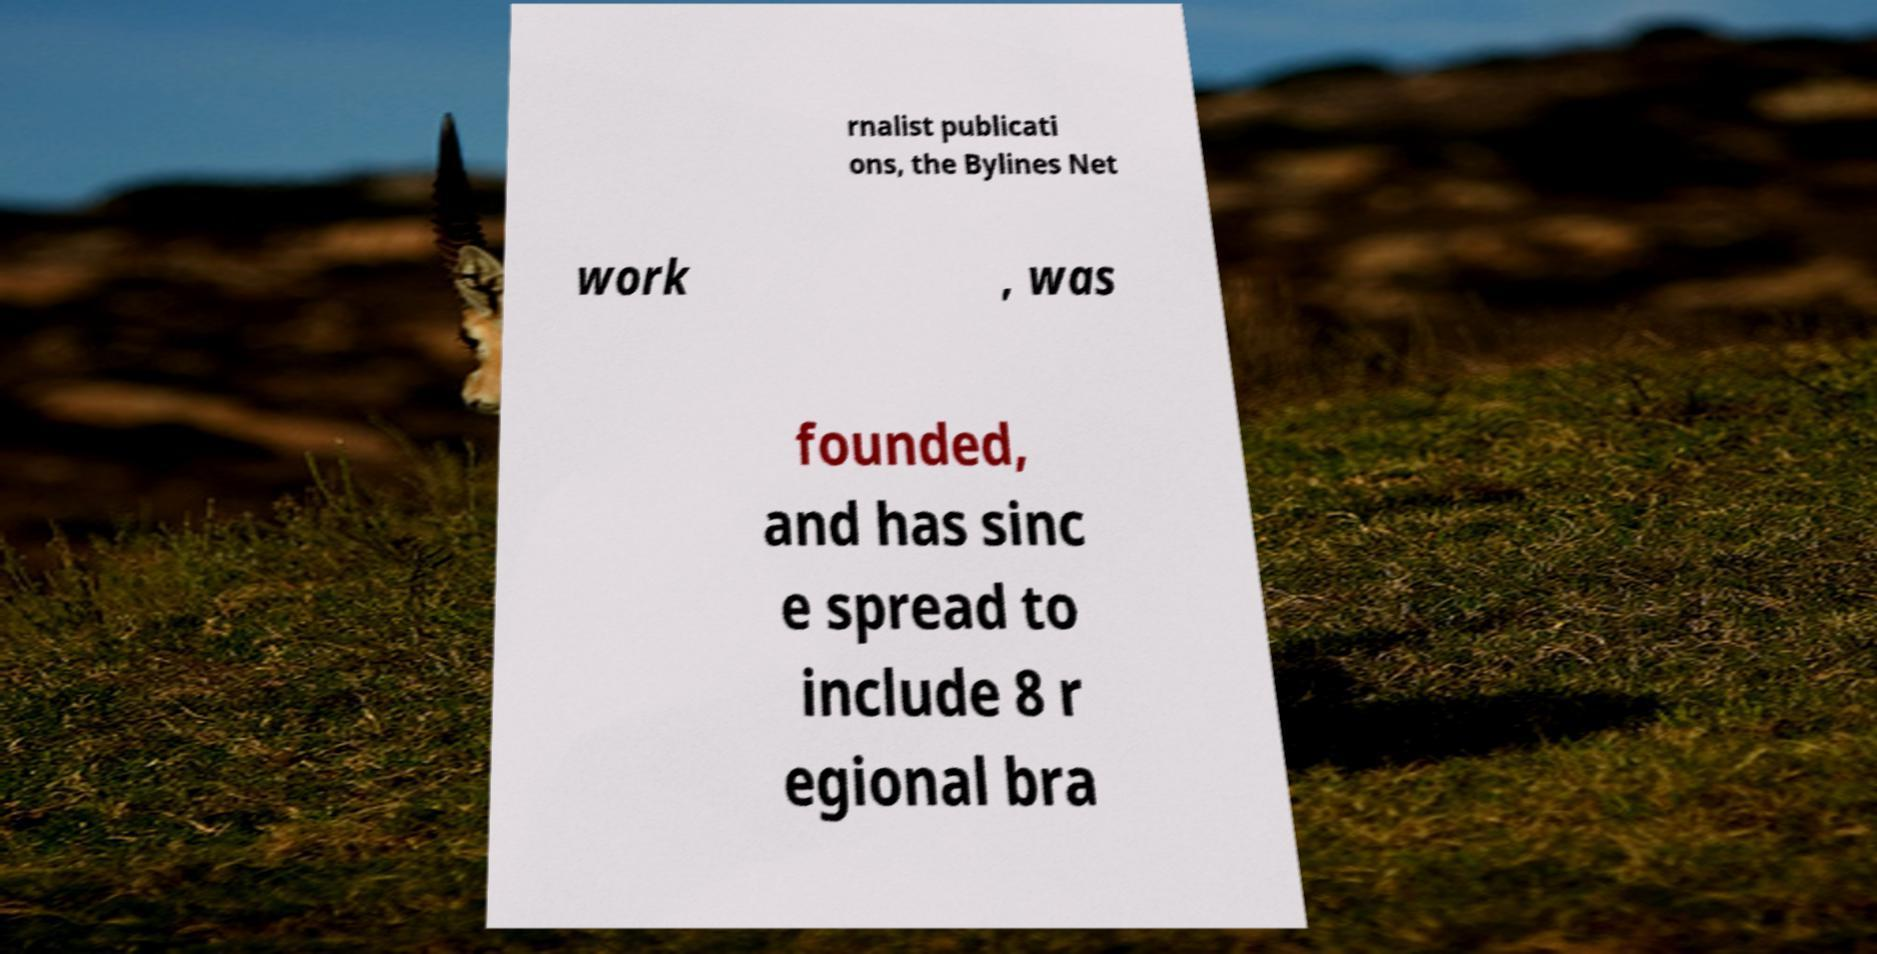Can you read and provide the text displayed in the image?This photo seems to have some interesting text. Can you extract and type it out for me? rnalist publicati ons, the Bylines Net work , was founded, and has sinc e spread to include 8 r egional bra 